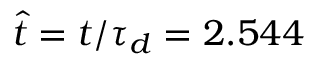<formula> <loc_0><loc_0><loc_500><loc_500>\hat { t } = t / \tau _ { d } = 2 . 5 4 4</formula> 